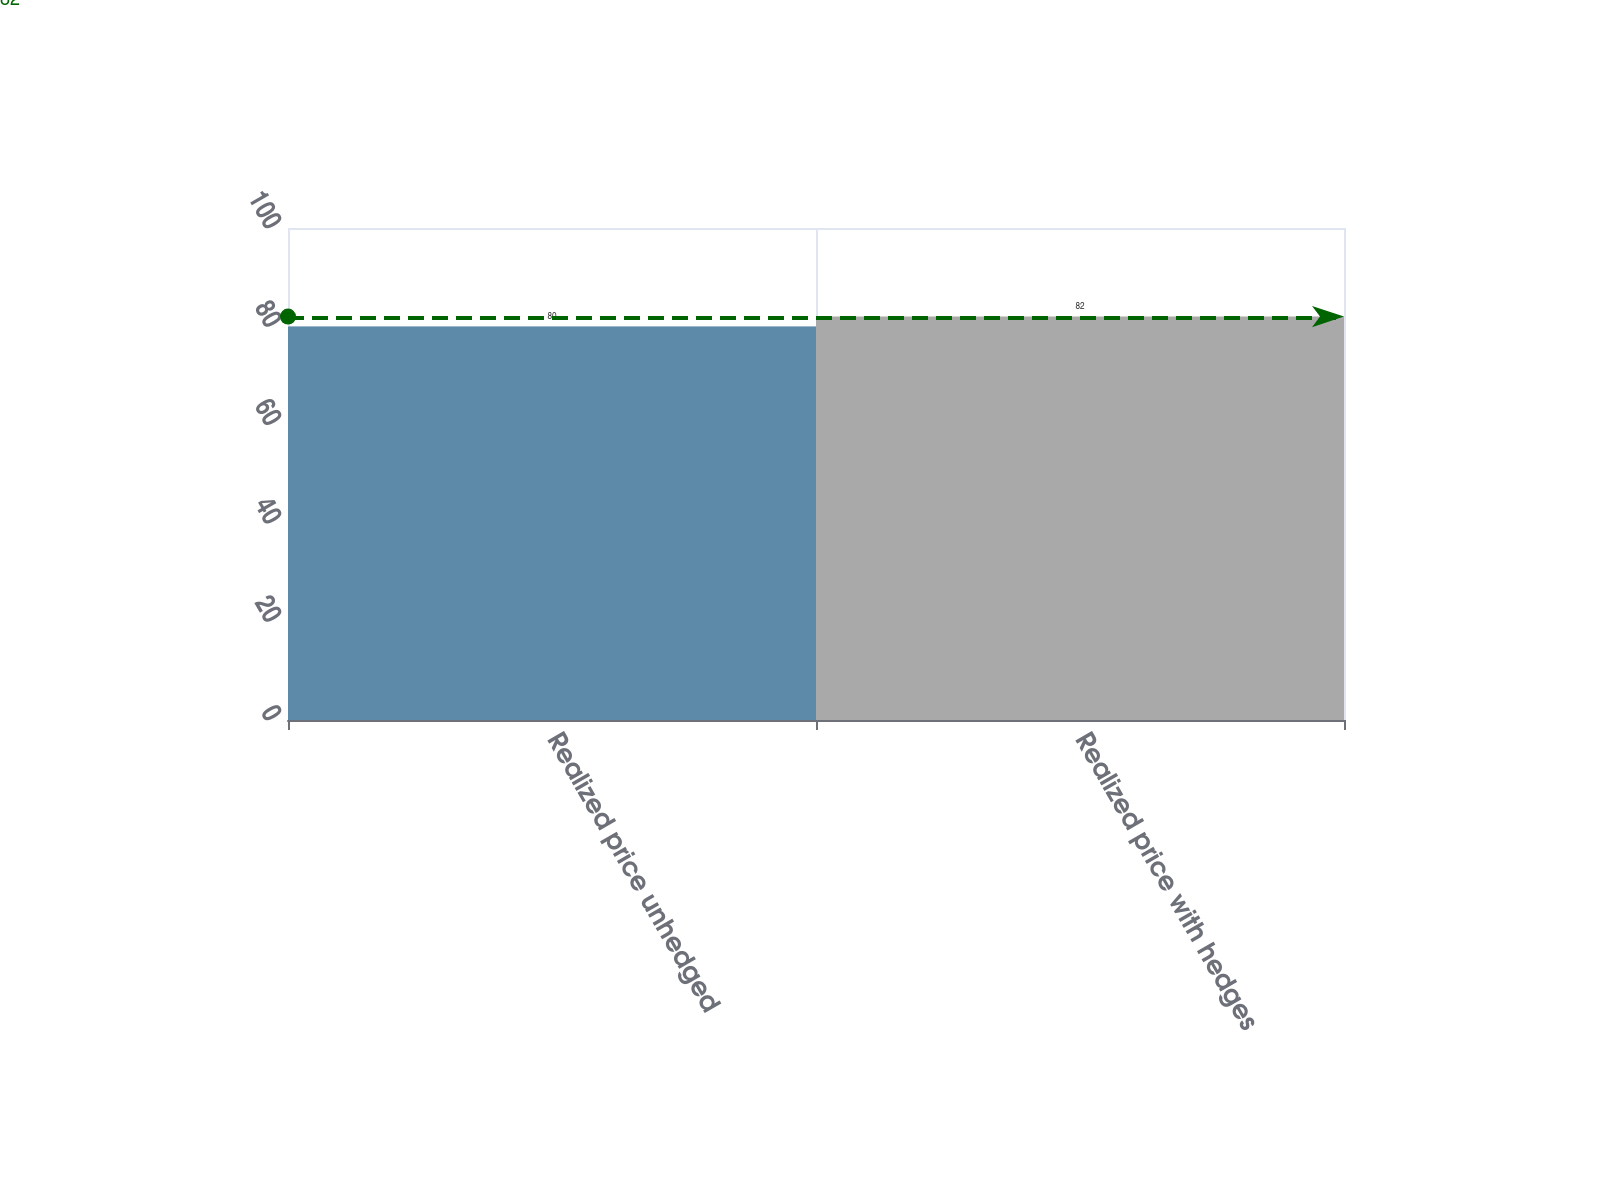<chart> <loc_0><loc_0><loc_500><loc_500><bar_chart><fcel>Realized price unhedged<fcel>Realized price with hedges<nl><fcel>80<fcel>82<nl></chart> 